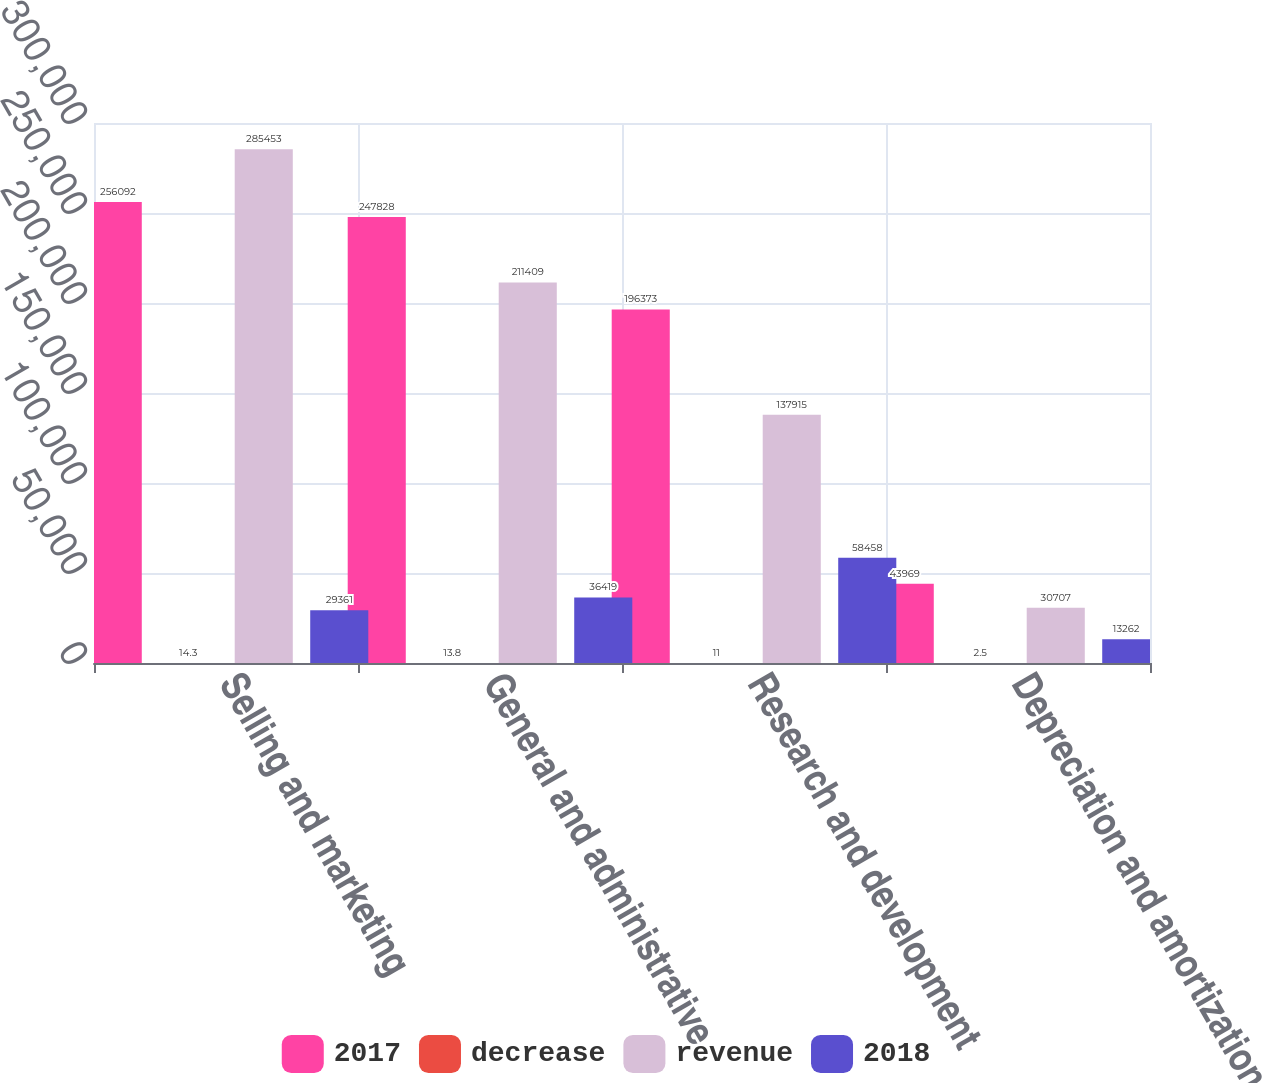<chart> <loc_0><loc_0><loc_500><loc_500><stacked_bar_chart><ecel><fcel>Selling and marketing<fcel>General and administrative<fcel>Research and development<fcel>Depreciation and amortization<nl><fcel>2017<fcel>256092<fcel>247828<fcel>196373<fcel>43969<nl><fcel>decrease<fcel>14.3<fcel>13.8<fcel>11<fcel>2.5<nl><fcel>revenue<fcel>285453<fcel>211409<fcel>137915<fcel>30707<nl><fcel>2018<fcel>29361<fcel>36419<fcel>58458<fcel>13262<nl></chart> 